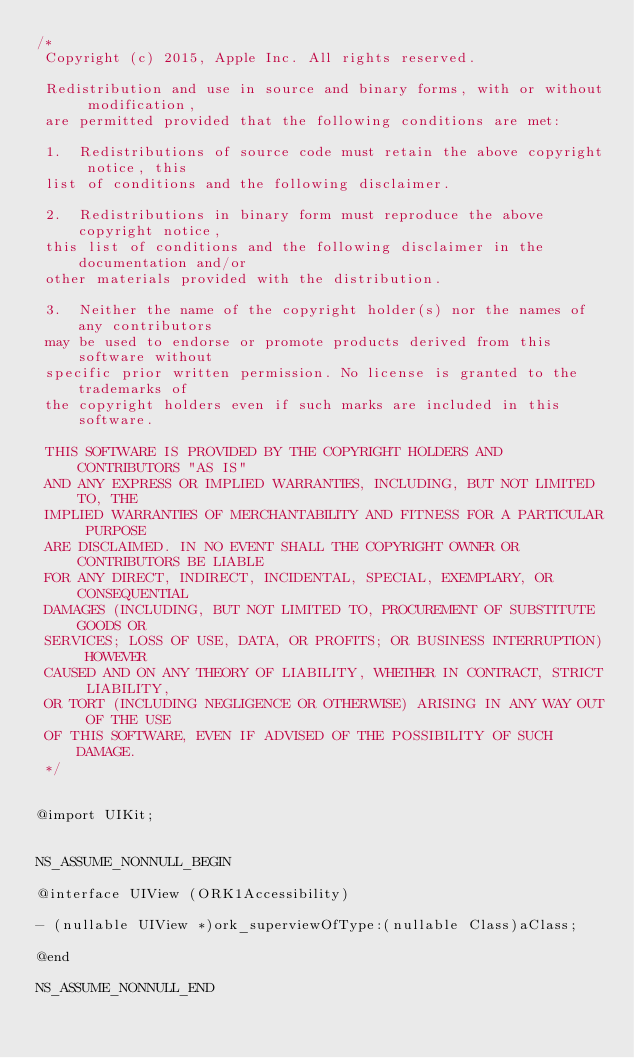Convert code to text. <code><loc_0><loc_0><loc_500><loc_500><_C_>/*
 Copyright (c) 2015, Apple Inc. All rights reserved.
 
 Redistribution and use in source and binary forms, with or without modification,
 are permitted provided that the following conditions are met:
 
 1.  Redistributions of source code must retain the above copyright notice, this
 list of conditions and the following disclaimer.
 
 2.  Redistributions in binary form must reproduce the above copyright notice,
 this list of conditions and the following disclaimer in the documentation and/or
 other materials provided with the distribution.
 
 3.  Neither the name of the copyright holder(s) nor the names of any contributors
 may be used to endorse or promote products derived from this software without
 specific prior written permission. No license is granted to the trademarks of
 the copyright holders even if such marks are included in this software.
 
 THIS SOFTWARE IS PROVIDED BY THE COPYRIGHT HOLDERS AND CONTRIBUTORS "AS IS"
 AND ANY EXPRESS OR IMPLIED WARRANTIES, INCLUDING, BUT NOT LIMITED TO, THE
 IMPLIED WARRANTIES OF MERCHANTABILITY AND FITNESS FOR A PARTICULAR PURPOSE
 ARE DISCLAIMED. IN NO EVENT SHALL THE COPYRIGHT OWNER OR CONTRIBUTORS BE LIABLE
 FOR ANY DIRECT, INDIRECT, INCIDENTAL, SPECIAL, EXEMPLARY, OR CONSEQUENTIAL
 DAMAGES (INCLUDING, BUT NOT LIMITED TO, PROCUREMENT OF SUBSTITUTE GOODS OR
 SERVICES; LOSS OF USE, DATA, OR PROFITS; OR BUSINESS INTERRUPTION) HOWEVER
 CAUSED AND ON ANY THEORY OF LIABILITY, WHETHER IN CONTRACT, STRICT LIABILITY,
 OR TORT (INCLUDING NEGLIGENCE OR OTHERWISE) ARISING IN ANY WAY OUT OF THE USE
 OF THIS SOFTWARE, EVEN IF ADVISED OF THE POSSIBILITY OF SUCH DAMAGE.
 */


@import UIKit;


NS_ASSUME_NONNULL_BEGIN

@interface UIView (ORK1Accessibility)

- (nullable UIView *)ork_superviewOfType:(nullable Class)aClass;

@end

NS_ASSUME_NONNULL_END
</code> 